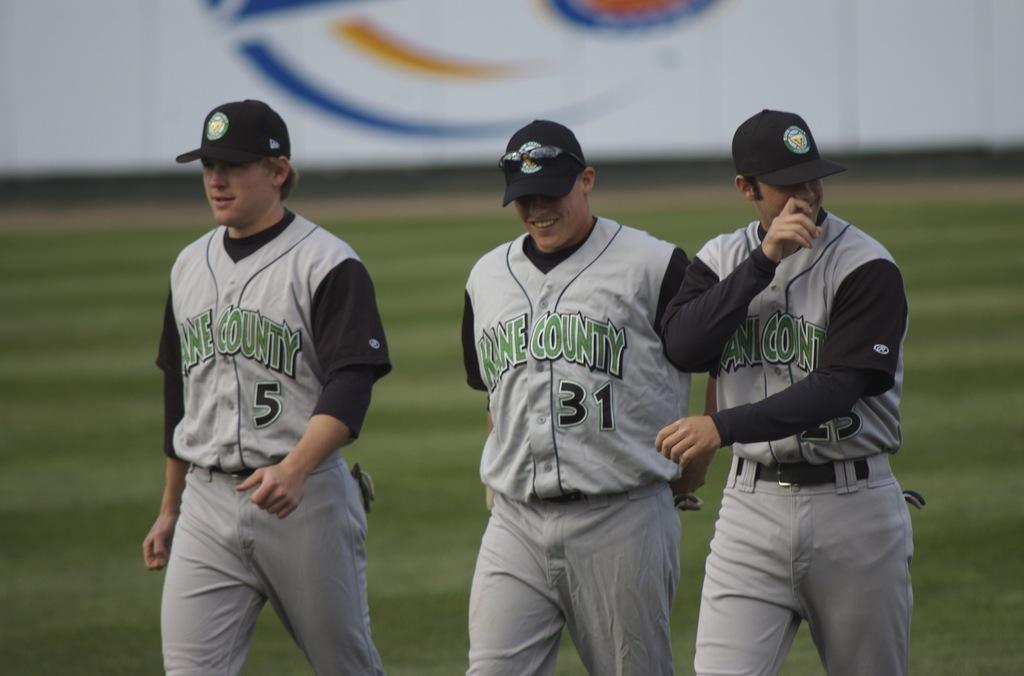How many people are in the image? There are three players in the image. What are the players wearing? The players are wearing grey dresses and black hats. What are the players doing in the image? The players are walking on the ground. Can you see any cobwebs in the image? There is no mention of cobwebs in the image, so we cannot determine if they are present or not. What are the players writing in the image? There is no indication that the players are writing anything in the image. 